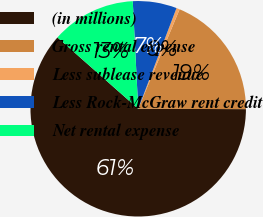Convert chart. <chart><loc_0><loc_0><loc_500><loc_500><pie_chart><fcel>(in millions)<fcel>Gross rental expense<fcel>Less sublease revenue<fcel>Less Rock-McGraw rent credit<fcel>Net rental expense<nl><fcel>61.46%<fcel>18.78%<fcel>0.49%<fcel>6.59%<fcel>12.68%<nl></chart> 